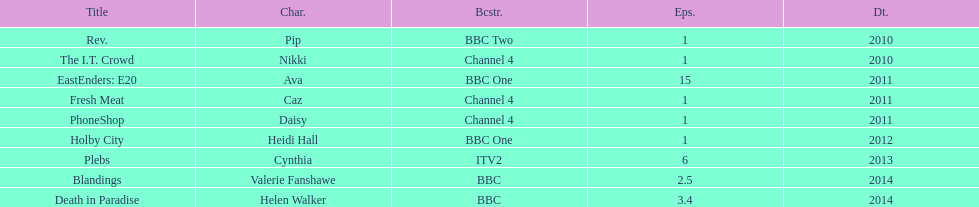How many titles only had one episode? 5. 